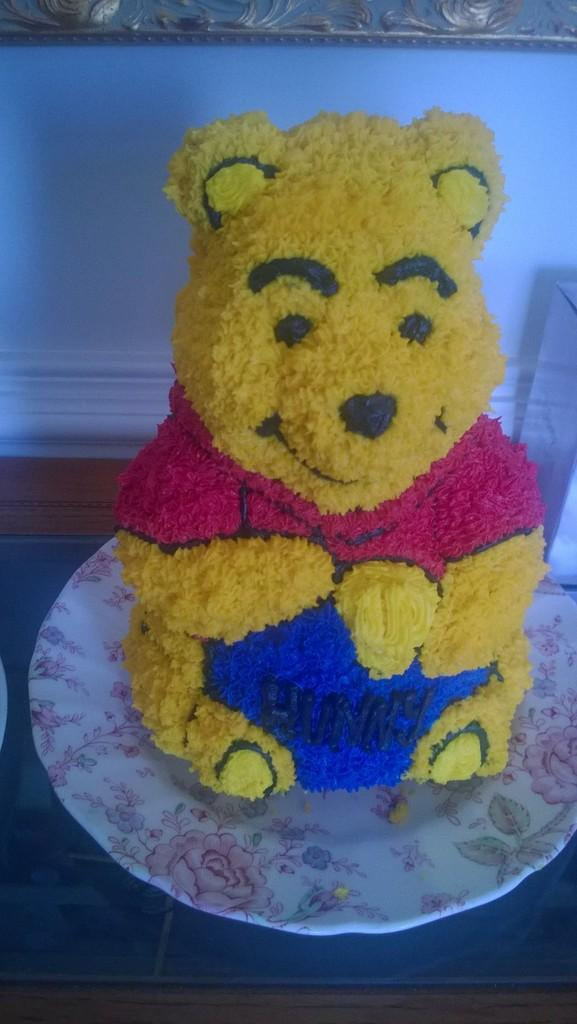What is the main subject of the image? The main subject of the image is a doll made with food items. Where is the doll placed? The doll is placed on a plate. On what surface is the plate kept? The plate is kept on a table. What type of linen is used to cover the doll in the image? There is no linen or cloth covering the doll in the image; it is made entirely of food items. What type of steel material is used to create the doll in the image? The doll in the image is made entirely of food items and not of any steel material. 